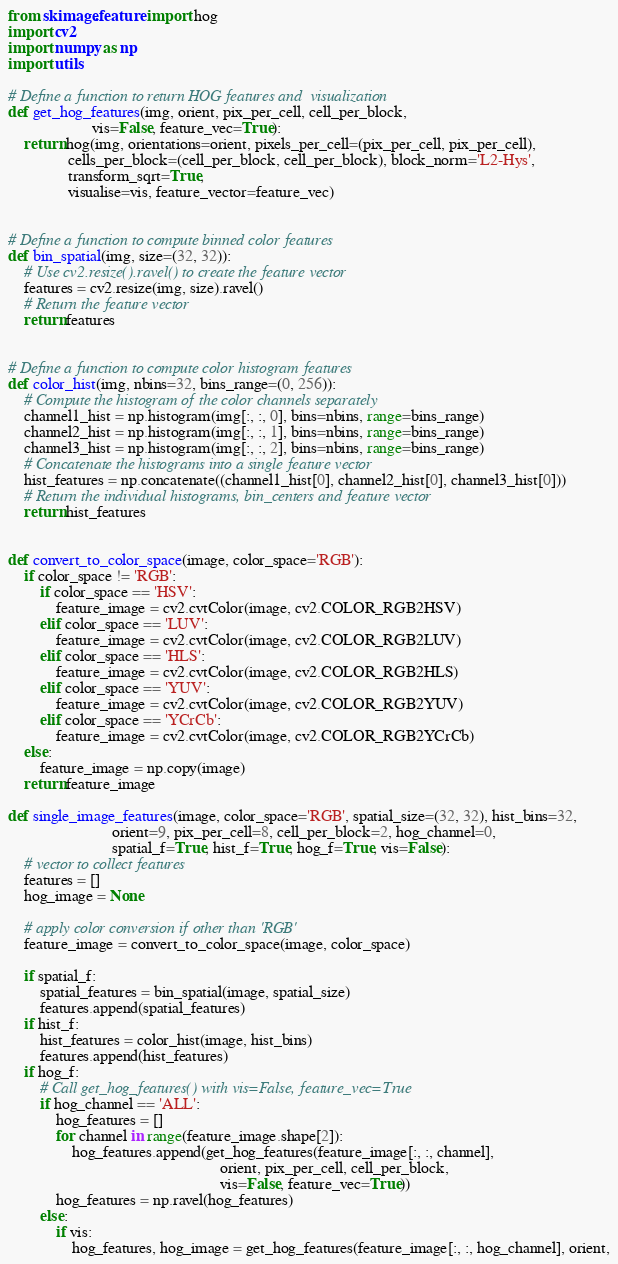<code> <loc_0><loc_0><loc_500><loc_500><_Python_>from skimage.feature import hog
import cv2
import numpy as np
import utils

# Define a function to return HOG features and  visualization
def get_hog_features(img, orient, pix_per_cell, cell_per_block,
                     vis=False, feature_vec=True):
    return hog(img, orientations=orient, pixels_per_cell=(pix_per_cell, pix_per_cell),
               cells_per_block=(cell_per_block, cell_per_block), block_norm='L2-Hys',
               transform_sqrt=True,
               visualise=vis, feature_vector=feature_vec)


# Define a function to compute binned color features
def bin_spatial(img, size=(32, 32)):
    # Use cv2.resize().ravel() to create the feature vector
    features = cv2.resize(img, size).ravel()
    # Return the feature vector
    return features


# Define a function to compute color histogram features
def color_hist(img, nbins=32, bins_range=(0, 256)):
    # Compute the histogram of the color channels separately
    channel1_hist = np.histogram(img[:, :, 0], bins=nbins, range=bins_range)
    channel2_hist = np.histogram(img[:, :, 1], bins=nbins, range=bins_range)
    channel3_hist = np.histogram(img[:, :, 2], bins=nbins, range=bins_range)
    # Concatenate the histograms into a single feature vector
    hist_features = np.concatenate((channel1_hist[0], channel2_hist[0], channel3_hist[0]))
    # Return the individual histograms, bin_centers and feature vector
    return hist_features


def convert_to_color_space(image, color_space='RGB'):
    if color_space != 'RGB':
        if color_space == 'HSV':
            feature_image = cv2.cvtColor(image, cv2.COLOR_RGB2HSV)
        elif color_space == 'LUV':
            feature_image = cv2.cvtColor(image, cv2.COLOR_RGB2LUV)
        elif color_space == 'HLS':
            feature_image = cv2.cvtColor(image, cv2.COLOR_RGB2HLS)
        elif color_space == 'YUV':
            feature_image = cv2.cvtColor(image, cv2.COLOR_RGB2YUV)
        elif color_space == 'YCrCb':
            feature_image = cv2.cvtColor(image, cv2.COLOR_RGB2YCrCb)
    else:
        feature_image = np.copy(image)
    return feature_image

def single_image_features(image, color_space='RGB', spatial_size=(32, 32), hist_bins=32,
                          orient=9, pix_per_cell=8, cell_per_block=2, hog_channel=0,
                          spatial_f=True, hist_f=True, hog_f=True, vis=False):
    # vector to collect features
    features = []
    hog_image = None

    # apply color conversion if other than 'RGB'
    feature_image = convert_to_color_space(image, color_space)

    if spatial_f:
        spatial_features = bin_spatial(image, spatial_size)
        features.append(spatial_features)
    if hist_f:
        hist_features = color_hist(image, hist_bins)
        features.append(hist_features)
    if hog_f:
        # Call get_hog_features() with vis=False, feature_vec=True
        if hog_channel == 'ALL':
            hog_features = []
            for channel in range(feature_image.shape[2]):
                hog_features.append(get_hog_features(feature_image[:, :, channel],
                                                     orient, pix_per_cell, cell_per_block,
                                                     vis=False, feature_vec=True))
            hog_features = np.ravel(hog_features)
        else:
            if vis:
                hog_features, hog_image = get_hog_features(feature_image[:, :, hog_channel], orient,</code> 